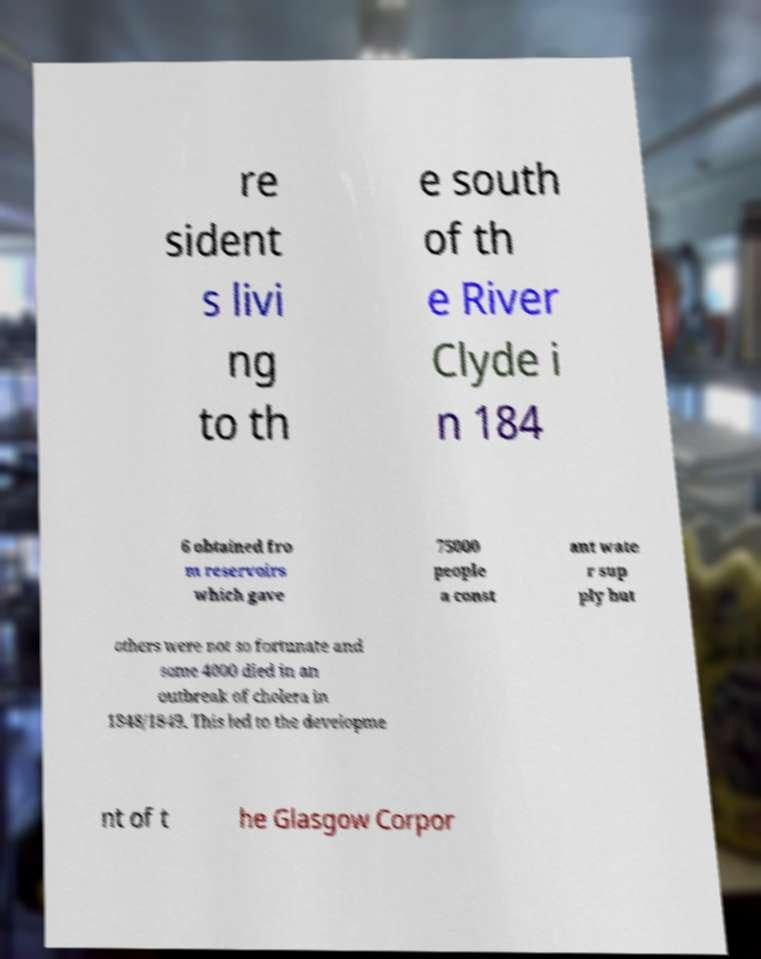Can you read and provide the text displayed in the image?This photo seems to have some interesting text. Can you extract and type it out for me? re sident s livi ng to th e south of th e River Clyde i n 184 6 obtained fro m reservoirs which gave 75000 people a const ant wate r sup ply but others were not so fortunate and some 4000 died in an outbreak of cholera in 1848/1849. This led to the developme nt of t he Glasgow Corpor 